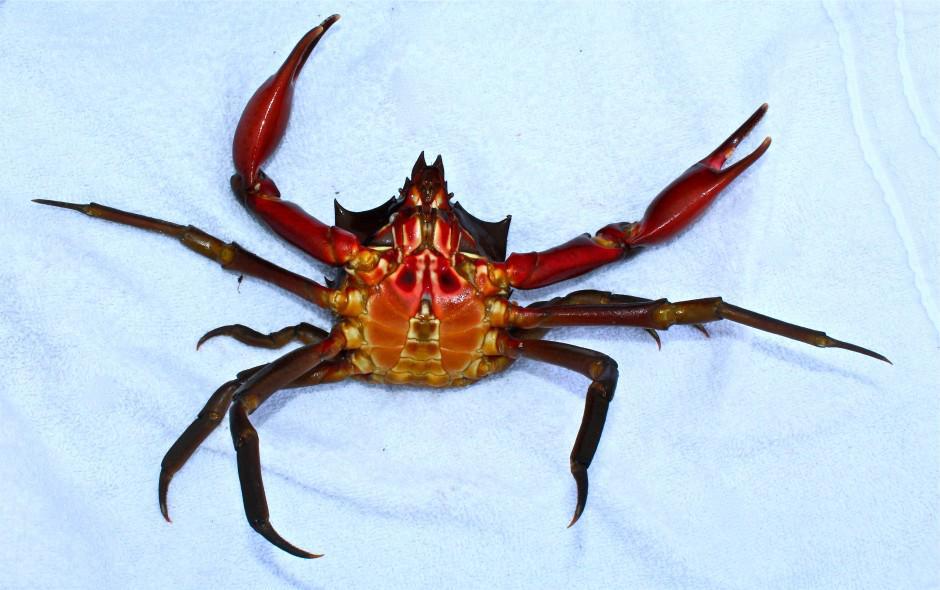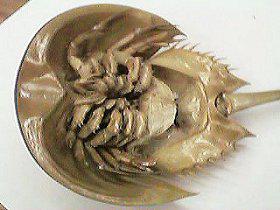The first image is the image on the left, the second image is the image on the right. For the images displayed, is the sentence "Both pictures show the underside of one crab and all are positioned in the same way." factually correct? Answer yes or no. No. The first image is the image on the left, the second image is the image on the right. Evaluate the accuracy of this statement regarding the images: "Each image is a bottom view of a single crab with its head at the top of the image and its front claws pointed toward each other.". Is it true? Answer yes or no. No. 